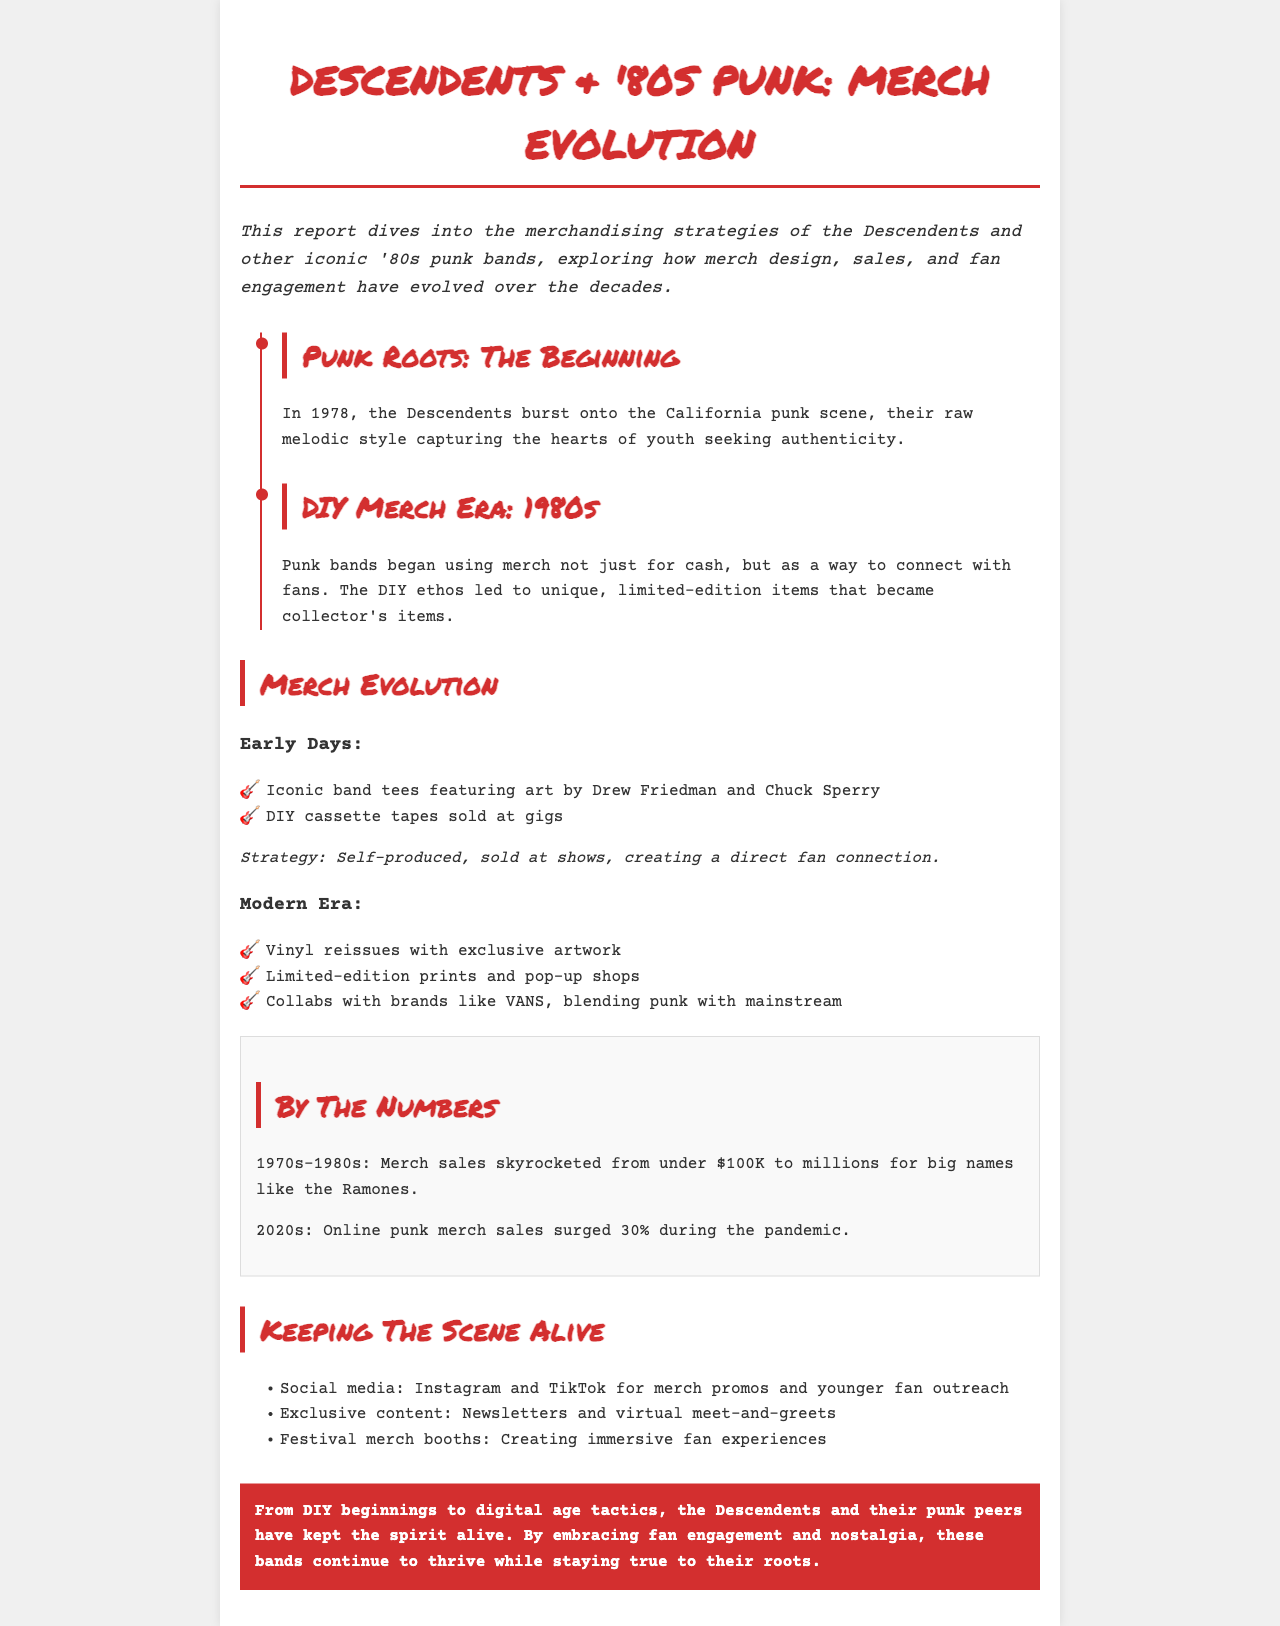What year did the Descendents emerge? The document states that the Descendents burst onto the scene in 1978.
Answer: 1978 What were two early merchandise items? The report lists iconic band tees and DIY cassette tapes as early merchandise items.
Answer: Band tees, cassette tapes What significant merch sales milestone occurred in the 1970s-1980s? The document indicates that merch sales skyrocketed from under $100K to millions.
Answer: Millions Which social media platforms are mentioned for fan engagement? The report mentions Instagram and TikTok as platforms for merchandise promotion.
Answer: Instagram, TikTok How did the merch strategy change in the modern era? The document describes the modern era strategy as including vinyl reissues and limited-edition prints.
Answer: Vinyl reissues, limited-edition prints What is a key fan engagement tactic mentioned in the document? The report highlights exclusive content like newsletters and virtual meet-and-greets as a fan engagement tactic.
Answer: Exclusive content What kind of items did punk bands use as collector's items in the DIY merch era? It states that unique, limited-edition items became collector's items during the DIY merch era.
Answer: Unique items What does the conclusion emphasize about the Descendents and punk bands? The conclusion emphasizes that these bands continue to thrive while staying true to their roots.
Answer: Staying true to their roots 